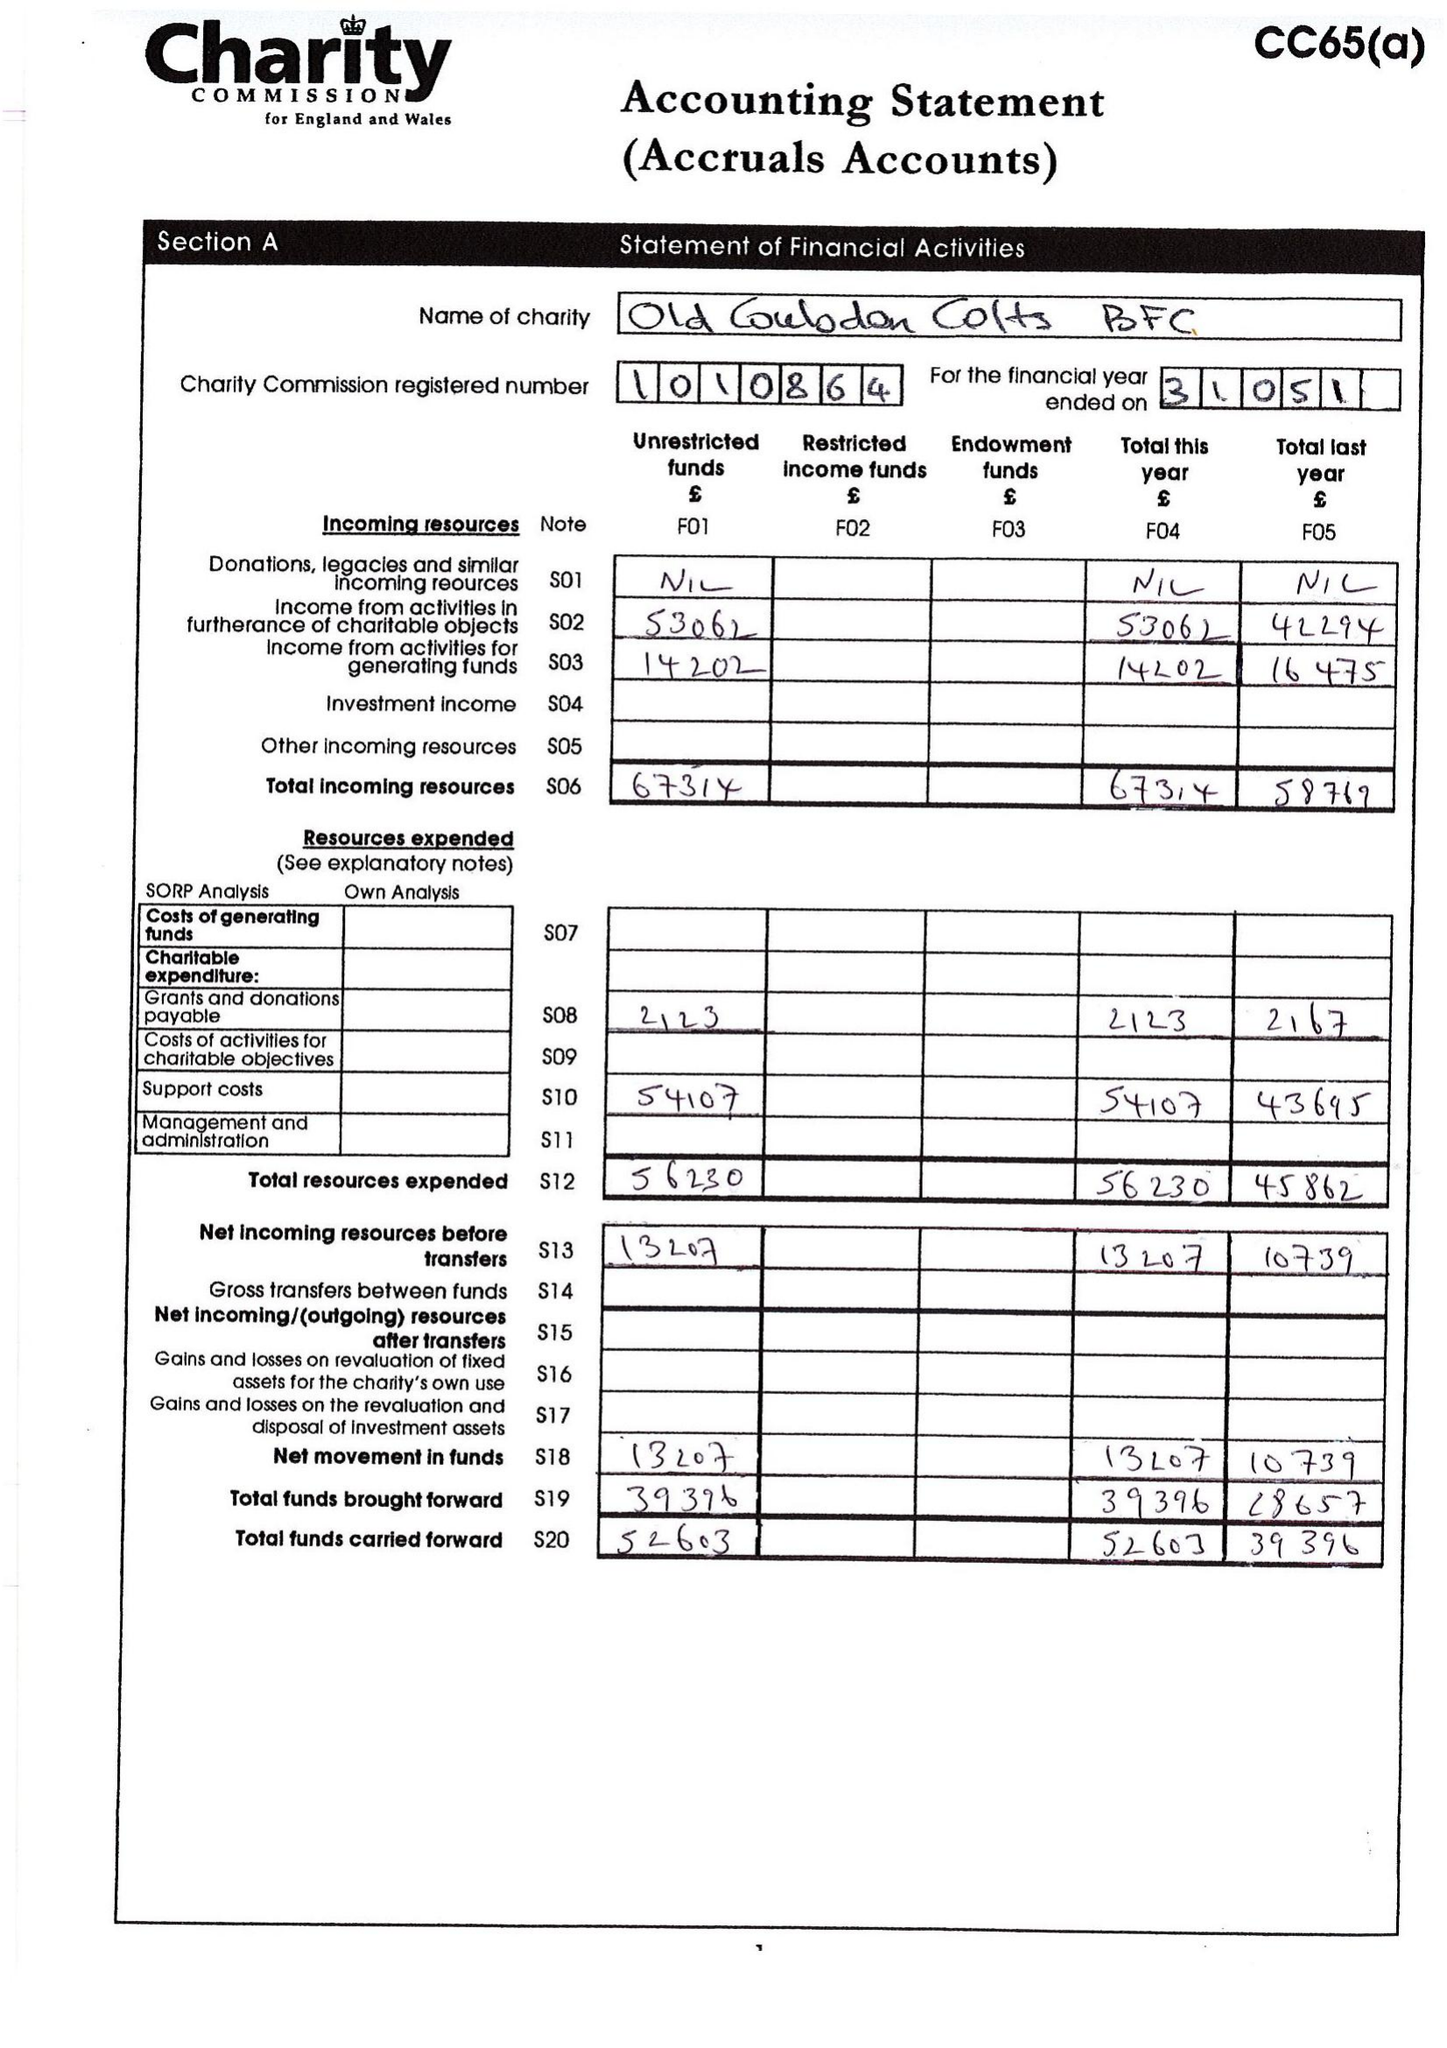What is the value for the address__street_line?
Answer the question using a single word or phrase. 77 TOLLERS LANE 